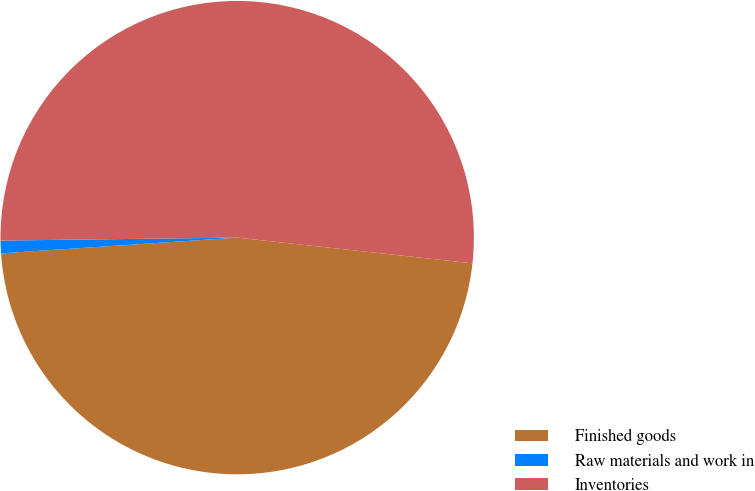<chart> <loc_0><loc_0><loc_500><loc_500><pie_chart><fcel>Finished goods<fcel>Raw materials and work in<fcel>Inventories<nl><fcel>47.21%<fcel>0.86%<fcel>51.93%<nl></chart> 